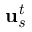Convert formula to latex. <formula><loc_0><loc_0><loc_500><loc_500>u _ { s } ^ { t }</formula> 